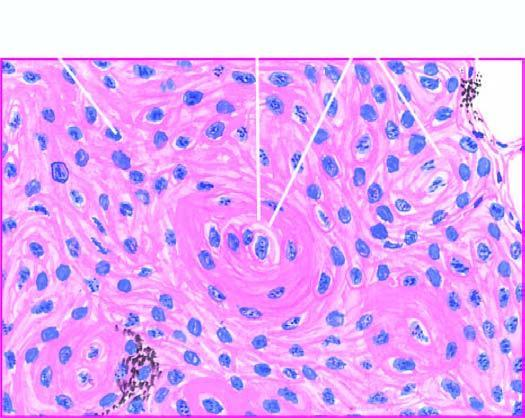re the opened up chambers of the heart seen?
Answer the question using a single word or phrase. No 